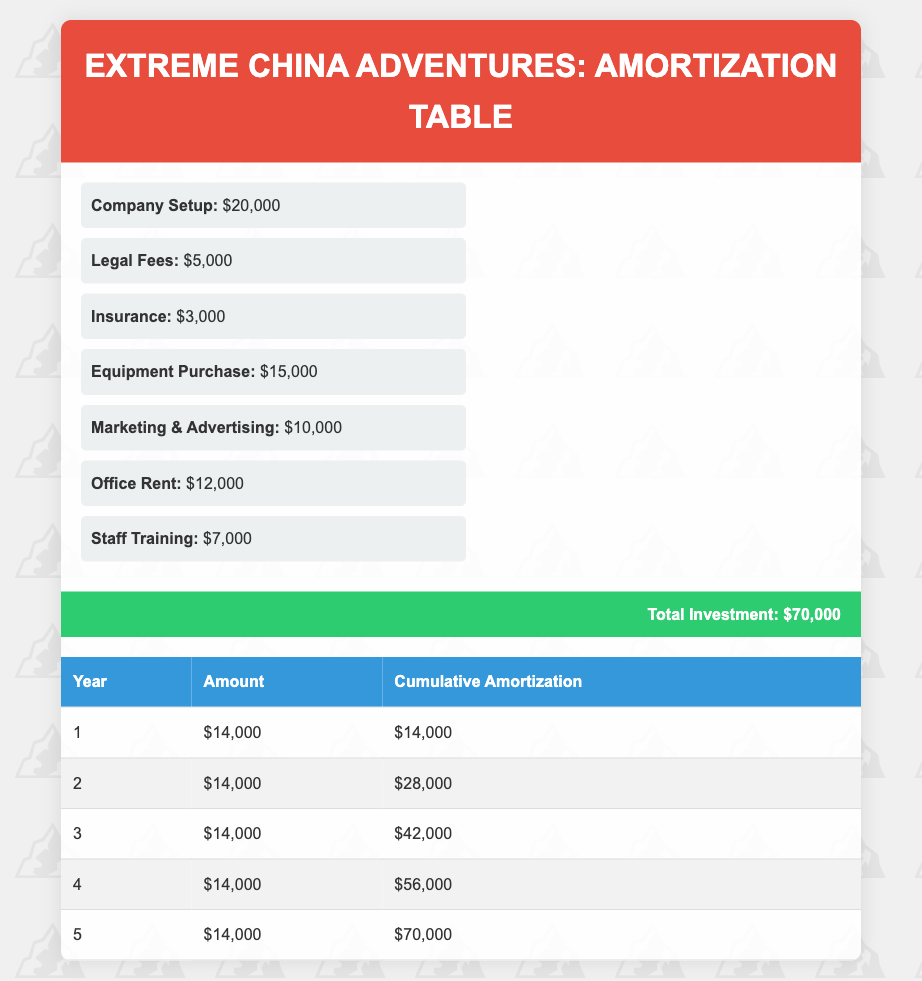What is the total amount to be amortized each year? Each year, the amount to be amortized is the same, which is $14,000 as seen in each row of the amortization schedule.
Answer: 14,000 What is the total investment amount? The table shows a section for total investment, which sums up all initial costs, amounting to $70,000.
Answer: 70,000 In which year does the cumulative amortization first reach $28,000? By examining the cumulative amortization column, it shows that in year 2 the cumulative amount reaches $28,000.
Answer: Year 2 Is the first year's amortization amount higher than the fifth year's? Since the table lists $14,000 for both the first and fifth years, they are equal, so the statement is false.
Answer: No What is the cumulative amortization after three years? By summing the amortization amounts for the first three years: $14,000 + $14,000 + $14,000 = $42,000, indicating the cumulative amount after three years.
Answer: 42,000 If the total investment is amortized equally over five years, what will be the average amount amortized per year? The total investment of $70,000 when divided by the five years gives us $70,000 / 5 = $14,000 per year, confirming the equal amortization each year.
Answer: 14,000 By how much did the cumulative amortization increase from year three to year four? The cumulative amortization for year three is $42,000, and for year four, it is $56,000. Therefore, the increase is $56,000 - $42,000 = $14,000.
Answer: 14,000 Is the amortization amount consistent throughout the five years? Since every year shows the same amount of $14,000 listed in the table, this is true, indicating a consistent amortization schedule.
Answer: Yes What percentage of the total investment has been amortized by the end of year 4? To find this percentage, divide the cumulative amortization by the total investment and multiply by 100: ($56,000 / $70,000) * 100 = 80%.
Answer: 80% 